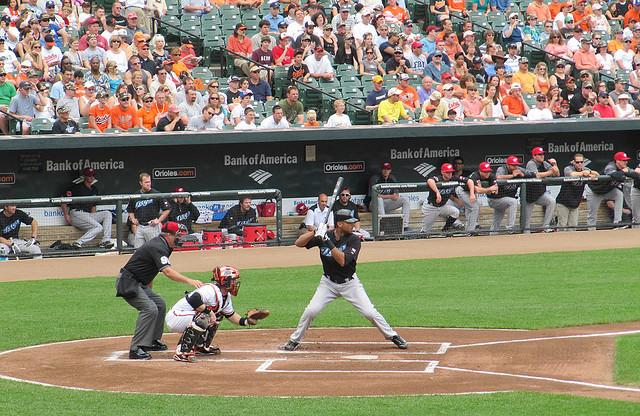What color helmet is the man with the bat wearing?
Answer briefly. Black. How many red caps on the players?
Be succinct. 5. Is the batter swinging left handed or right handed?
Concise answer only. Right. Is the match starting or has just ended?
Short answer required. Starting. What type of bat is the hitter holding?
Concise answer only. Baseball. 